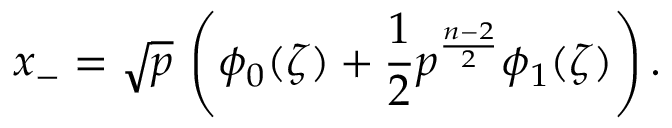<formula> <loc_0><loc_0><loc_500><loc_500>x _ { - } = \sqrt { p } \, \left ( \phi _ { 0 } ( \zeta ) + \frac { 1 } { 2 } p ^ { \frac { n - 2 } { 2 } } \phi _ { 1 } ( \zeta ) \right ) .</formula> 